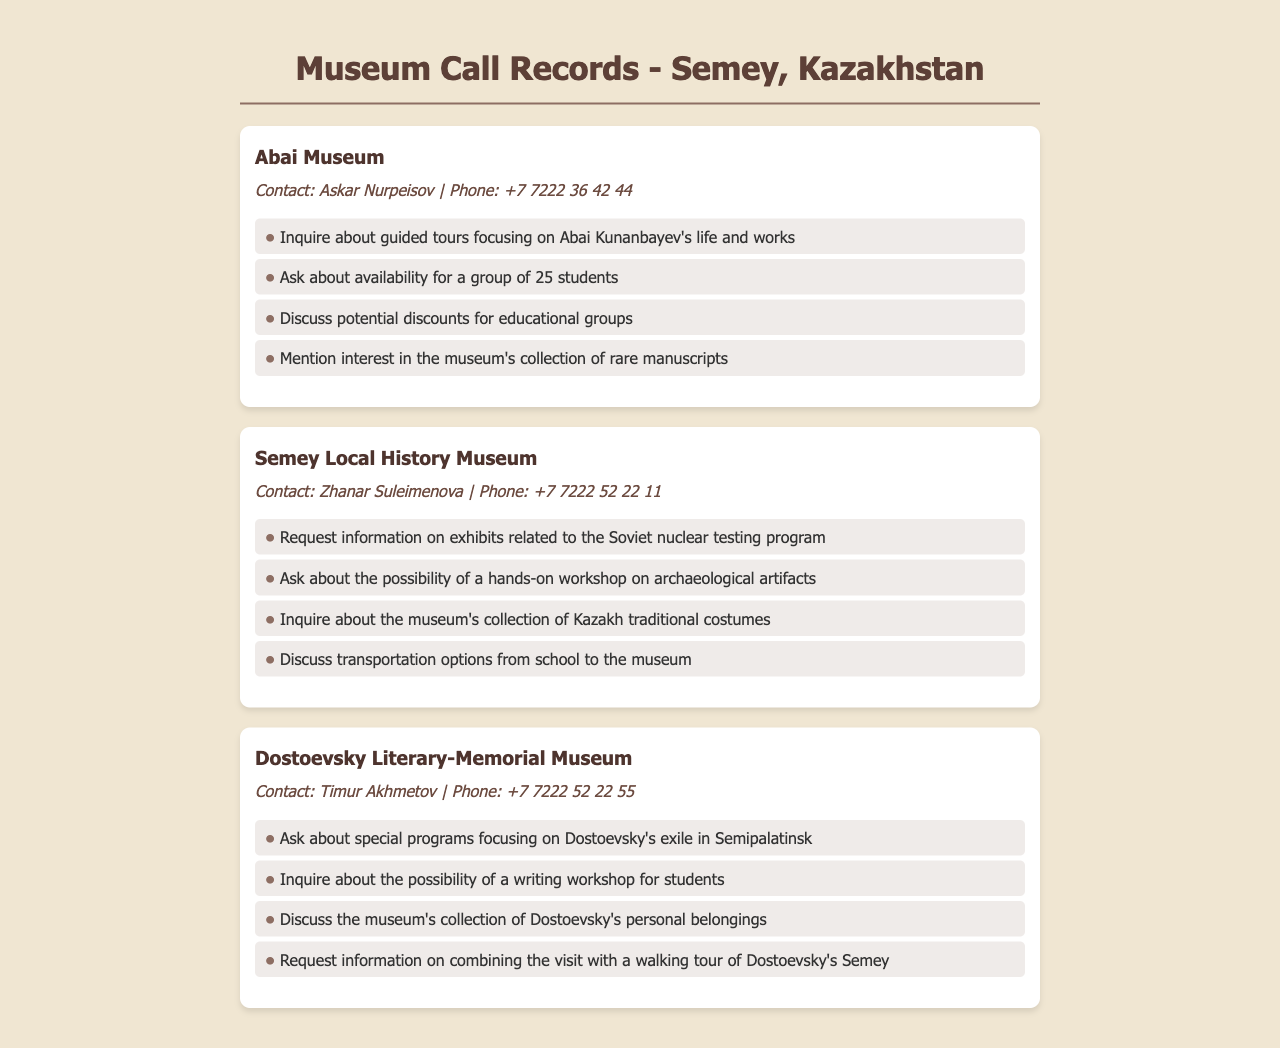what is the contact name for Abai Museum? The document lists the contact name for Abai Museum as Askar Nurpeisov.
Answer: Askar Nurpeisov how many students are being discussed for the Abai Museum visit? The document mentions a group of 25 students for the Abai Museum visit.
Answer: 25 students which museum has information related to the Soviet nuclear testing program? The Semey Local History Museum has exhibits related to the Soviet nuclear testing program.
Answer: Semey Local History Museum who is the contact person for the Dostoevsky Literary-Memorial Museum? The document states that the contact person for the Dostoevsky Literary-Memorial Museum is Timur Akhmetov.
Answer: Timur Akhmetov what type of workshop is offered at the Semey Local History Museum? The document describes a hands-on workshop on archaeological artifacts offered at the Semey Local History Museum.
Answer: hands-on workshop on archaeological artifacts what specific focus does the Dostoevsky museum suggest for the student program? The document indicates a focus on Dostoevsky's exile in Semipalatinsk for the student program at the Dostoevsky Literary-Memorial Museum.
Answer: Dostoevsky's exile in Semipalatinsk which museum is discussing transportation options from school? The Semey Local History Museum is discussing transportation options from school to the museum.
Answer: Semey Local History Museum is there a mention of traditional costumes in the document? Yes, the document mentions inquiries about the museum's collection of Kazakh traditional costumes at the Semey Local History Museum.
Answer: Kazakh traditional costumes what is the phone number for the Abai Museum? The Abai Museum's phone number is +7 7222 36 42 44 as listed in the document.
Answer: +7 7222 36 42 44 